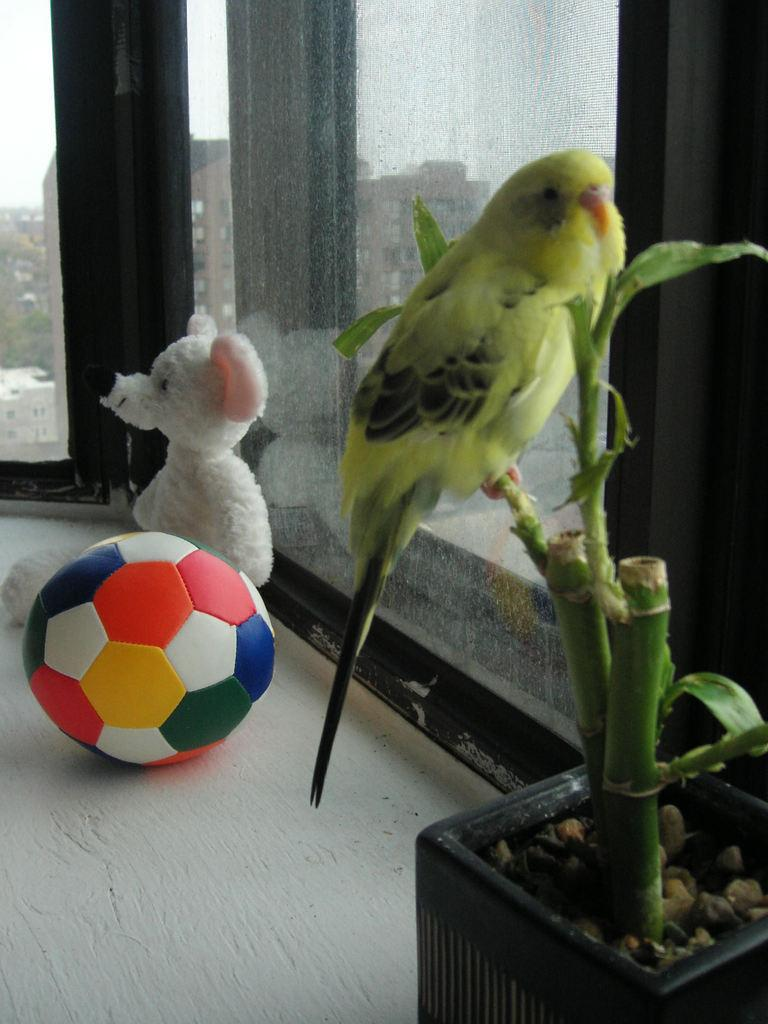What type of animal is in the image? There is a parrot in the image. Where is the parrot located in the image? The parrot is sitting on the stem of a plant. What other objects can be seen in the image? There is a ball and a teddy bear in the image. What type of cemetery can be seen in the background of the image? There is no cemetery present in the image; it features a parrot, a plant, a ball, and a teddy bear. 